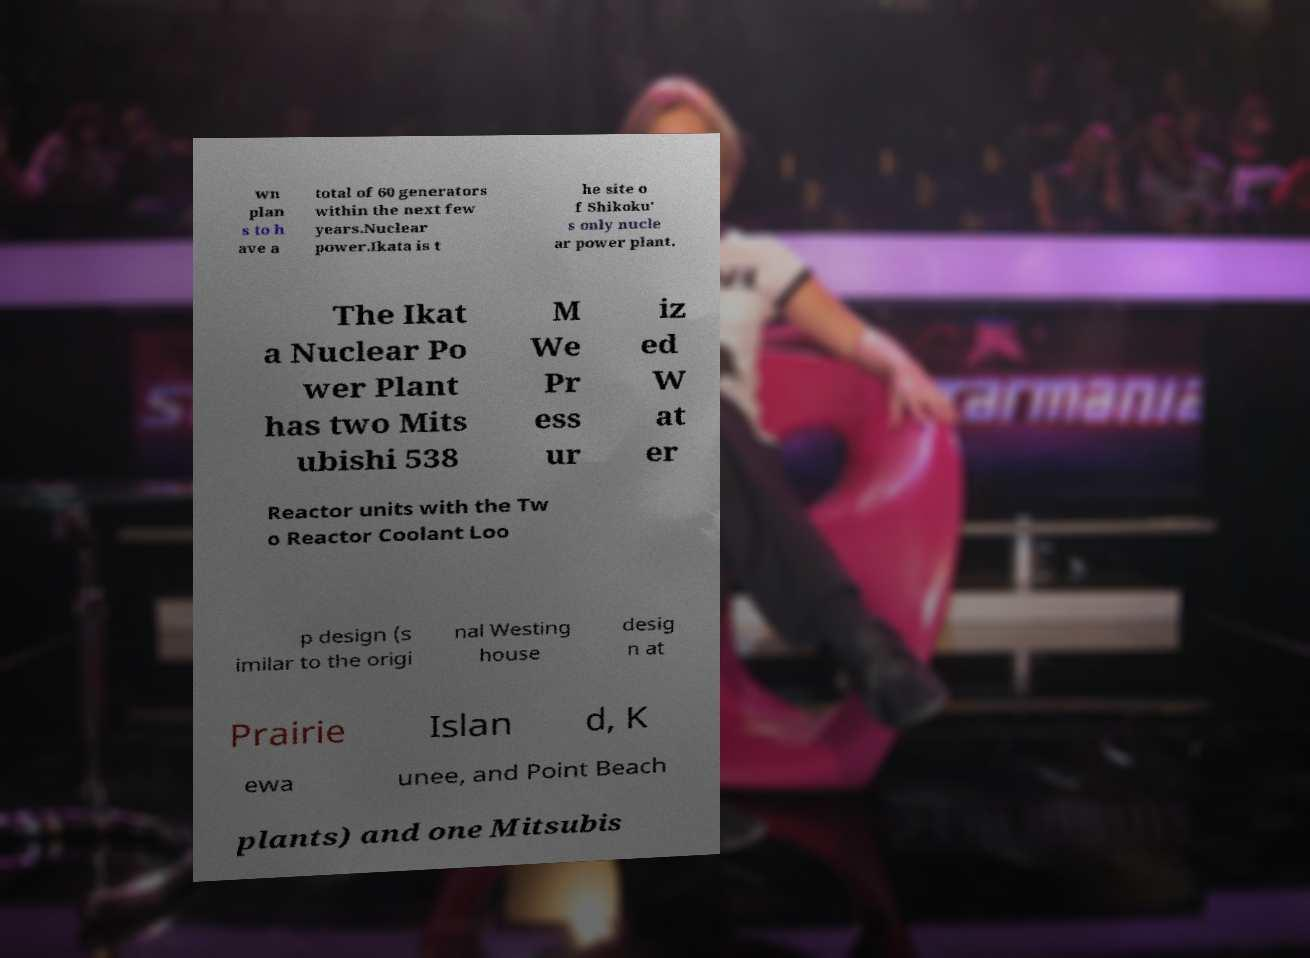I need the written content from this picture converted into text. Can you do that? wn plan s to h ave a total of 60 generators within the next few years.Nuclear power.Ikata is t he site o f Shikoku' s only nucle ar power plant. The Ikat a Nuclear Po wer Plant has two Mits ubishi 538 M We Pr ess ur iz ed W at er Reactor units with the Tw o Reactor Coolant Loo p design (s imilar to the origi nal Westing house desig n at Prairie Islan d, K ewa unee, and Point Beach plants) and one Mitsubis 